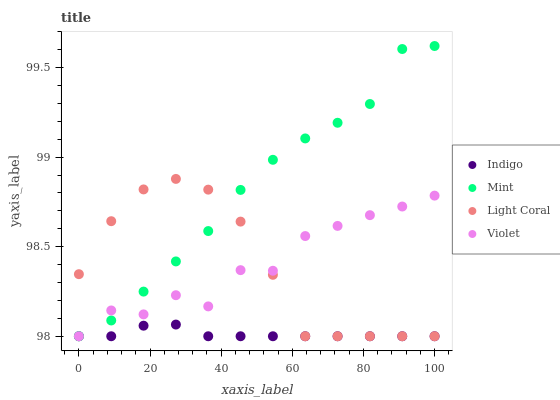Does Indigo have the minimum area under the curve?
Answer yes or no. Yes. Does Mint have the maximum area under the curve?
Answer yes or no. Yes. Does Mint have the minimum area under the curve?
Answer yes or no. No. Does Indigo have the maximum area under the curve?
Answer yes or no. No. Is Indigo the smoothest?
Answer yes or no. Yes. Is Violet the roughest?
Answer yes or no. Yes. Is Mint the smoothest?
Answer yes or no. No. Is Mint the roughest?
Answer yes or no. No. Does Light Coral have the lowest value?
Answer yes or no. Yes. Does Mint have the highest value?
Answer yes or no. Yes. Does Indigo have the highest value?
Answer yes or no. No. Does Light Coral intersect Indigo?
Answer yes or no. Yes. Is Light Coral less than Indigo?
Answer yes or no. No. Is Light Coral greater than Indigo?
Answer yes or no. No. 